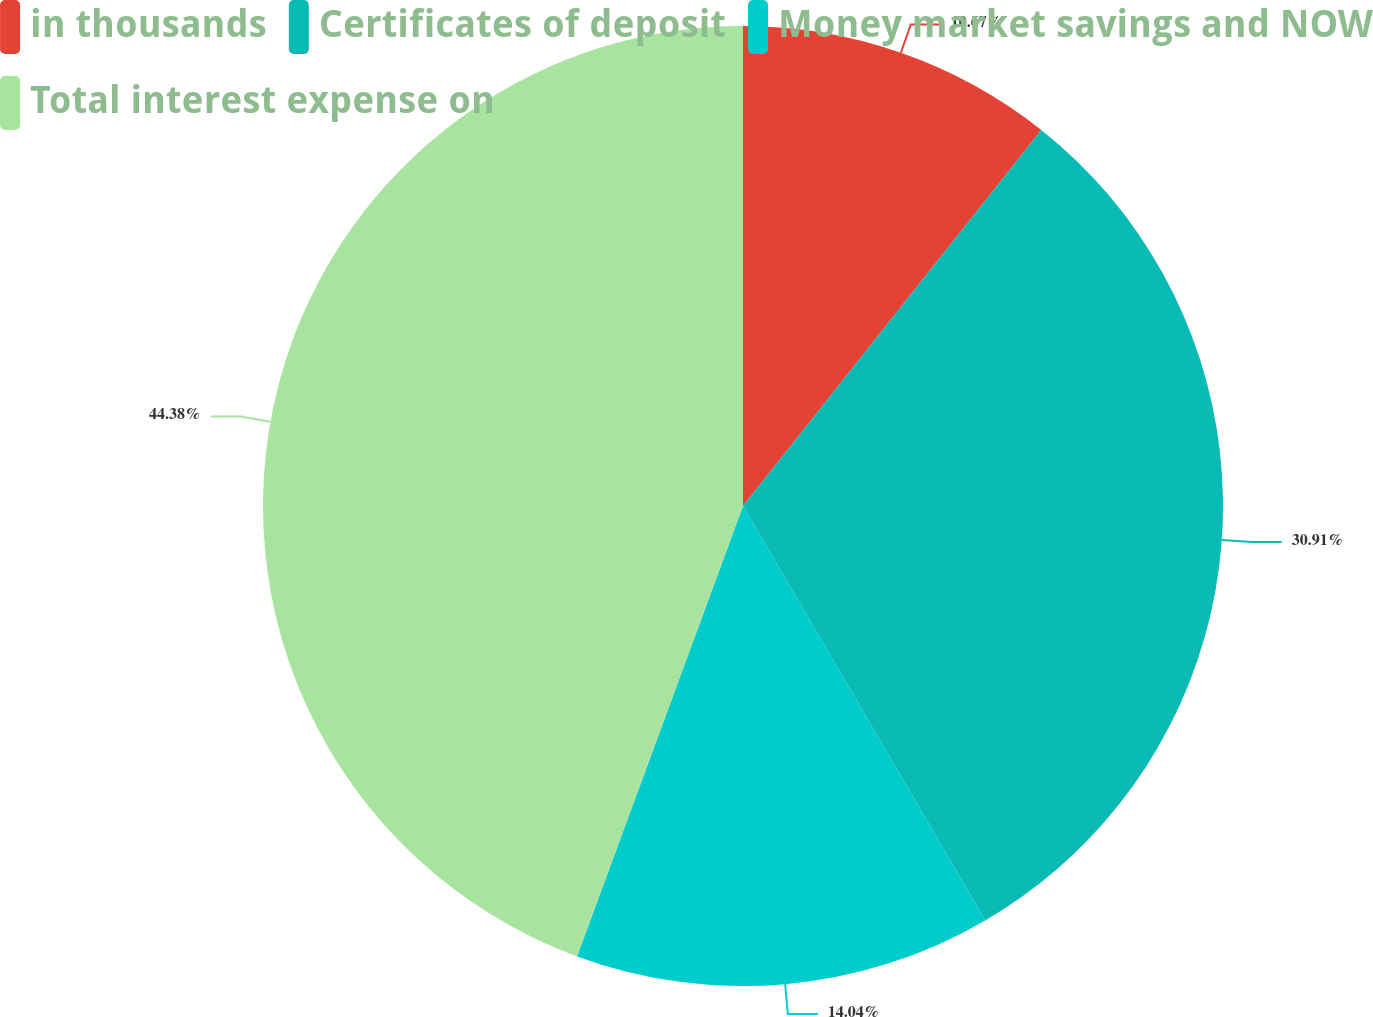Convert chart. <chart><loc_0><loc_0><loc_500><loc_500><pie_chart><fcel>in thousands<fcel>Certificates of deposit<fcel>Money market savings and NOW<fcel>Total interest expense on<nl><fcel>10.67%<fcel>30.91%<fcel>14.04%<fcel>44.38%<nl></chart> 